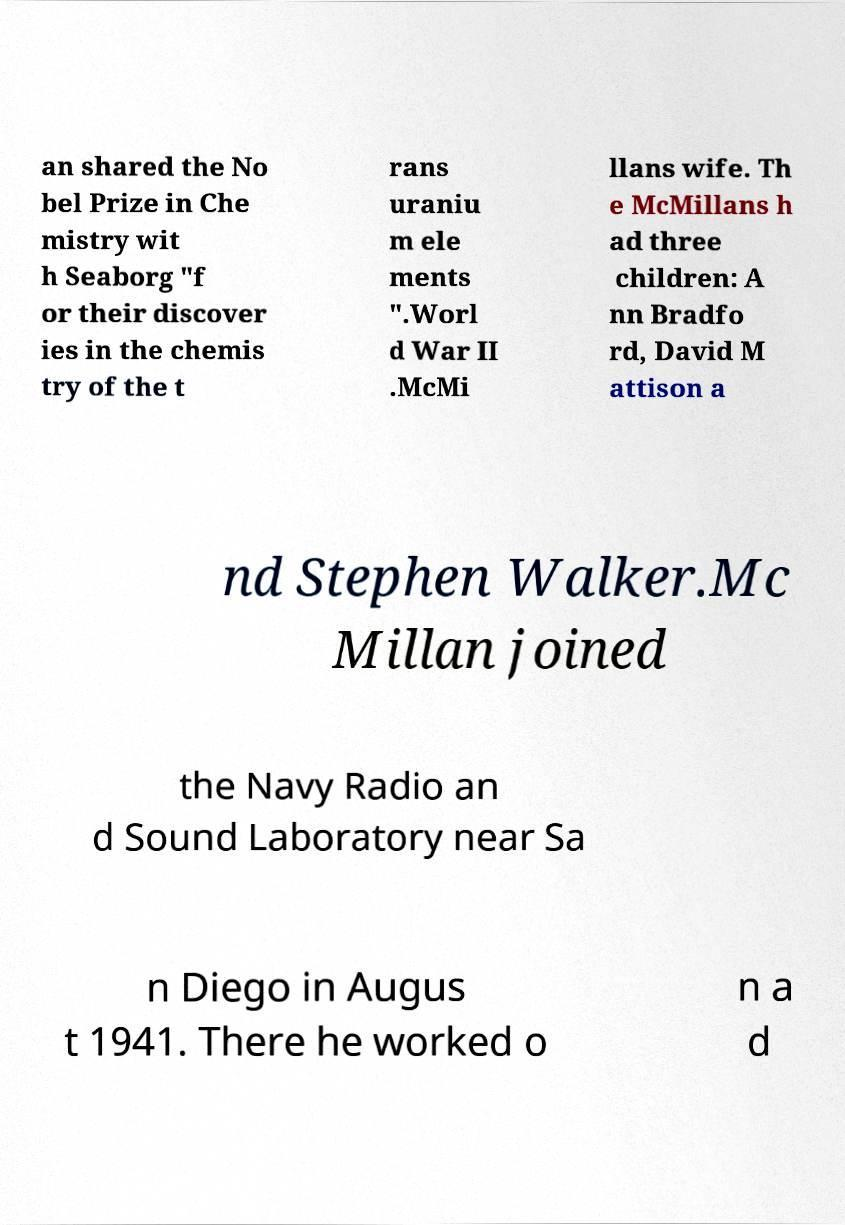Could you assist in decoding the text presented in this image and type it out clearly? an shared the No bel Prize in Che mistry wit h Seaborg "f or their discover ies in the chemis try of the t rans uraniu m ele ments ".Worl d War II .McMi llans wife. Th e McMillans h ad three children: A nn Bradfo rd, David M attison a nd Stephen Walker.Mc Millan joined the Navy Radio an d Sound Laboratory near Sa n Diego in Augus t 1941. There he worked o n a d 